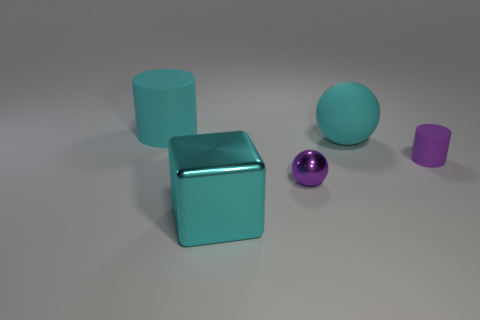What does the arrangement of these objects communicate, if it were an art installation? If this were an art installation, the arrangement of these objects could represent balance and order, with the regular shapes and spacing conveying a sense of deliberate design. The contrasting colors and sizes might symbolize diversity or the uniqueness of individual elements within a unified whole. 